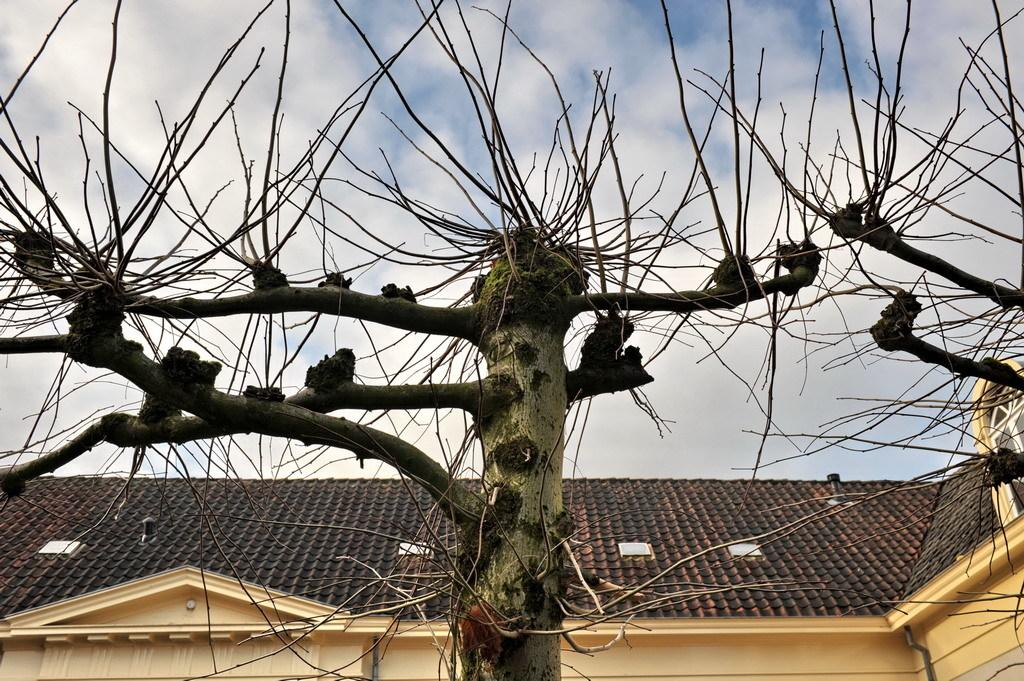What type of vegetation can be seen in the image? There are trees in the image. What is visible in the background of the image? There is a building in the background of the image. What part of the natural environment is visible in the image? The sky is visible in the image. What can be observed in the sky? Clouds are present in the sky. What type of lock can be seen on the trees in the image? There are no locks present on the trees in the image. What act is being performed by the clouds in the image? The clouds are not performing any act in the image; they are simply present in the sky. 